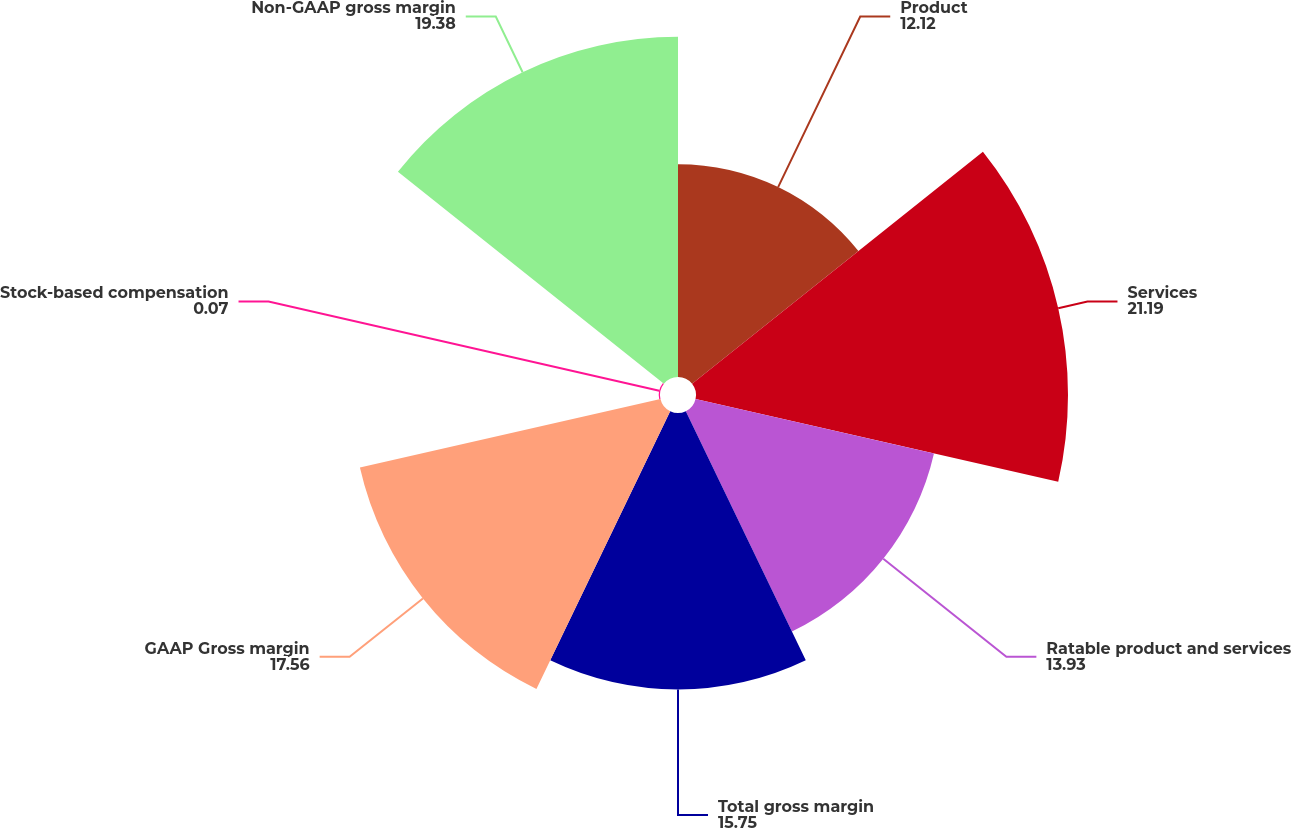<chart> <loc_0><loc_0><loc_500><loc_500><pie_chart><fcel>Product<fcel>Services<fcel>Ratable product and services<fcel>Total gross margin<fcel>GAAP Gross margin<fcel>Stock-based compensation<fcel>Non-GAAP gross margin<nl><fcel>12.12%<fcel>21.19%<fcel>13.93%<fcel>15.75%<fcel>17.56%<fcel>0.07%<fcel>19.38%<nl></chart> 